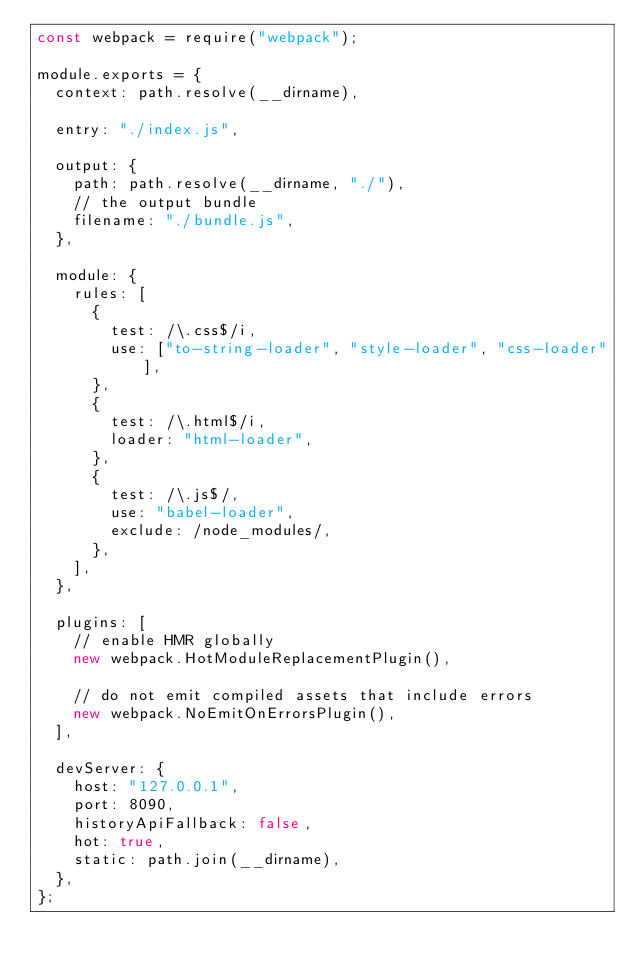<code> <loc_0><loc_0><loc_500><loc_500><_JavaScript_>const webpack = require("webpack");

module.exports = {
  context: path.resolve(__dirname),

  entry: "./index.js",

  output: {
    path: path.resolve(__dirname, "./"),
    // the output bundle
    filename: "./bundle.js",
  },

  module: {
    rules: [
      {
        test: /\.css$/i,
        use: ["to-string-loader", "style-loader", "css-loader"],
      },
      {
        test: /\.html$/i,
        loader: "html-loader",
      },
      {
        test: /\.js$/,
        use: "babel-loader",
        exclude: /node_modules/,
      },
    ],
  },

  plugins: [
    // enable HMR globally
    new webpack.HotModuleReplacementPlugin(),

    // do not emit compiled assets that include errors
    new webpack.NoEmitOnErrorsPlugin(),
  ],

  devServer: {
    host: "127.0.0.1",
    port: 8090,
    historyApiFallback: false,
    hot: true,
    static: path.join(__dirname),
  },
};
</code> 